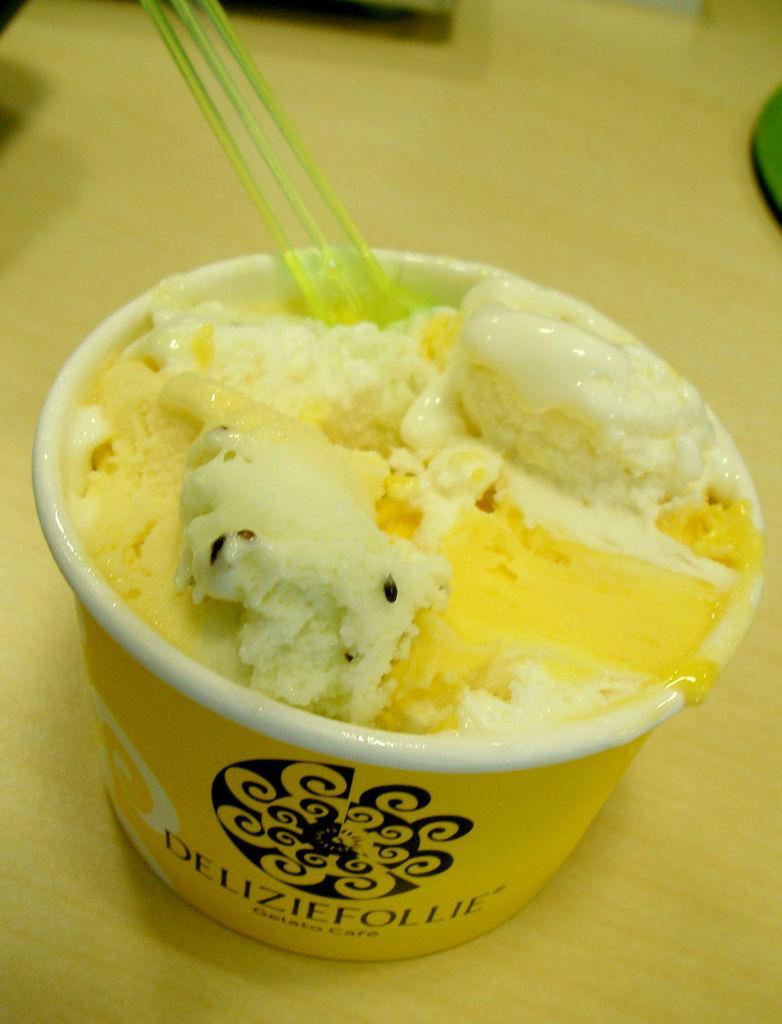Can you describe this image briefly? In this image we can see an ice cream, spoons in a cup and objects are on a platform. 